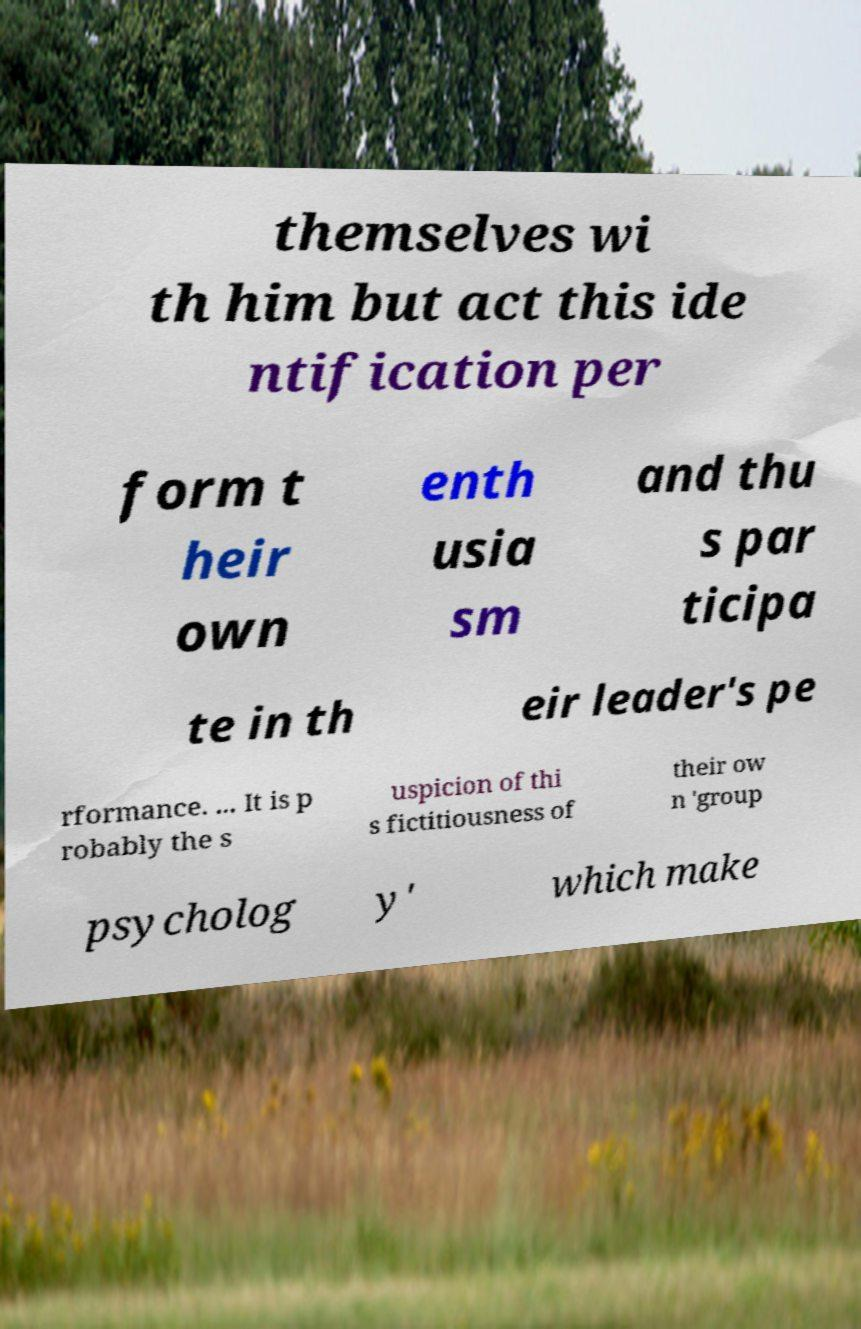Can you read and provide the text displayed in the image?This photo seems to have some interesting text. Can you extract and type it out for me? themselves wi th him but act this ide ntification per form t heir own enth usia sm and thu s par ticipa te in th eir leader's pe rformance. ... It is p robably the s uspicion of thi s fictitiousness of their ow n 'group psycholog y' which make 